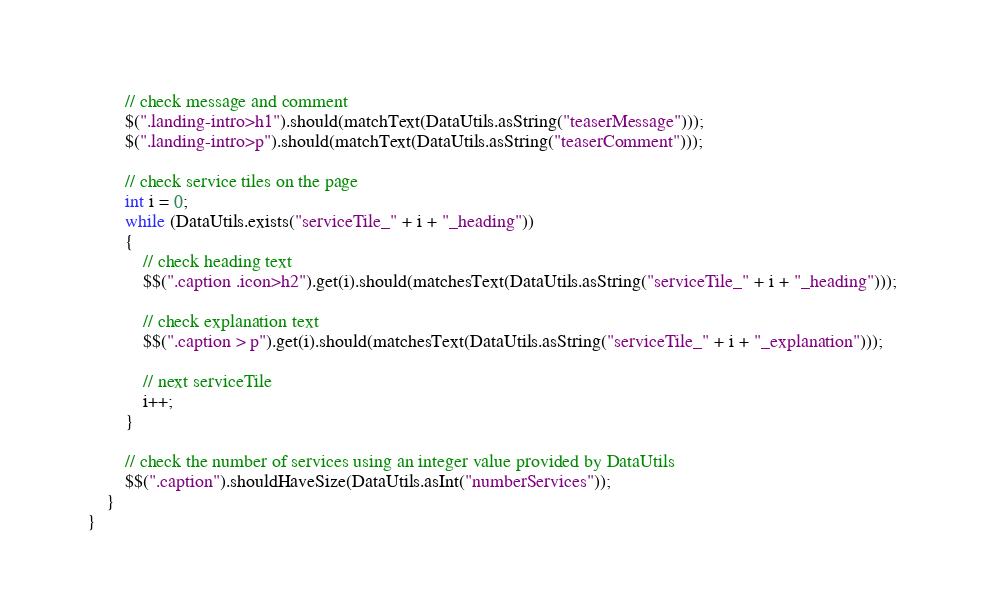<code> <loc_0><loc_0><loc_500><loc_500><_Java_>
        // check message and comment
        $(".landing-intro>h1").should(matchText(DataUtils.asString("teaserMessage")));
        $(".landing-intro>p").should(matchText(DataUtils.asString("teaserComment")));

        // check service tiles on the page
        int i = 0;
        while (DataUtils.exists("serviceTile_" + i + "_heading"))
        {
            // check heading text
            $$(".caption .icon>h2").get(i).should(matchesText(DataUtils.asString("serviceTile_" + i + "_heading")));

            // check explanation text
            $$(".caption > p").get(i).should(matchesText(DataUtils.asString("serviceTile_" + i + "_explanation")));

            // next serviceTile
            i++;
        }

        // check the number of services using an integer value provided by DataUtils
        $$(".caption").shouldHaveSize(DataUtils.asInt("numberServices"));
    }
}
</code> 